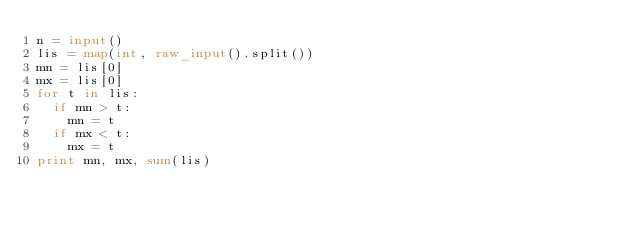Convert code to text. <code><loc_0><loc_0><loc_500><loc_500><_Python_>n = input()
lis = map(int, raw_input().split())
mn = lis[0]
mx = lis[0]
for t in lis:
	if mn > t:
		mn = t
	if mx < t:
		mx = t
print mn, mx, sum(lis)</code> 